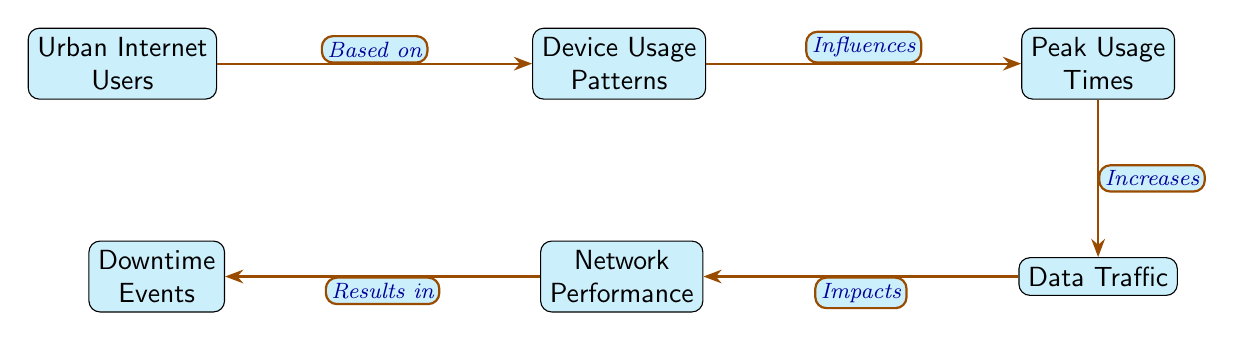What is the starting point of the food chain? The food chain starts with the node "Urban Internet Users," which indicates the source of influence on the subsequent nodes.
Answer: Urban Internet Users How many nodes are in the diagram? By counting the distinct labeled boxes in the diagram, there are a total of six nodes.
Answer: Six What does "Device Usage Patterns" influence? According to the arrows in the diagram, "Device Usage Patterns" influences "Peak Usage Times."
Answer: Peak Usage Times What is the impact of "Data Traffic" according to the diagram? "Data Traffic" impacts "Network Performance," as indicated by the directed edge flowing from "Data Traffic" to "Network Performance."
Answer: Network Performance What results from "Network Performance"? As shown in the lower part of the diagram, "Network Performance" results in "Downtime Events," representing a negative outcome of poor performance.
Answer: Downtime Events Which node is directly influenced by the usage patterns of urban users? The first direct influence after "Urban Internet Users" is the "Device Usage Patterns," as indicated by the arrow connecting the two nodes.
Answer: Device Usage Patterns How does "Peak Usage Times" affect data traffic? The diagram shows that "Peak Usage Times" increases "Data Traffic," detailing a causal relationship between higher usage times and data flow.
Answer: Increases What flows from "Traffic" to "Performance"? "Traffic" directly impacts "Performance," showing that the amount of data traffic influences the effectiveness and quality of the network.
Answer: Impacts What type of relationship exists between "Device Usage Patterns" and "Users"? The relationship is one of influence, signifying that the behaviors and patterns of users on devices directly affect subsequent network metrics.
Answer: Based on 